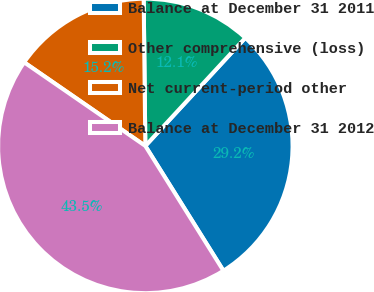Convert chart to OTSL. <chart><loc_0><loc_0><loc_500><loc_500><pie_chart><fcel>Balance at December 31 2011<fcel>Other comprehensive (loss)<fcel>Net current-period other<fcel>Balance at December 31 2012<nl><fcel>29.22%<fcel>12.06%<fcel>15.21%<fcel>43.51%<nl></chart> 